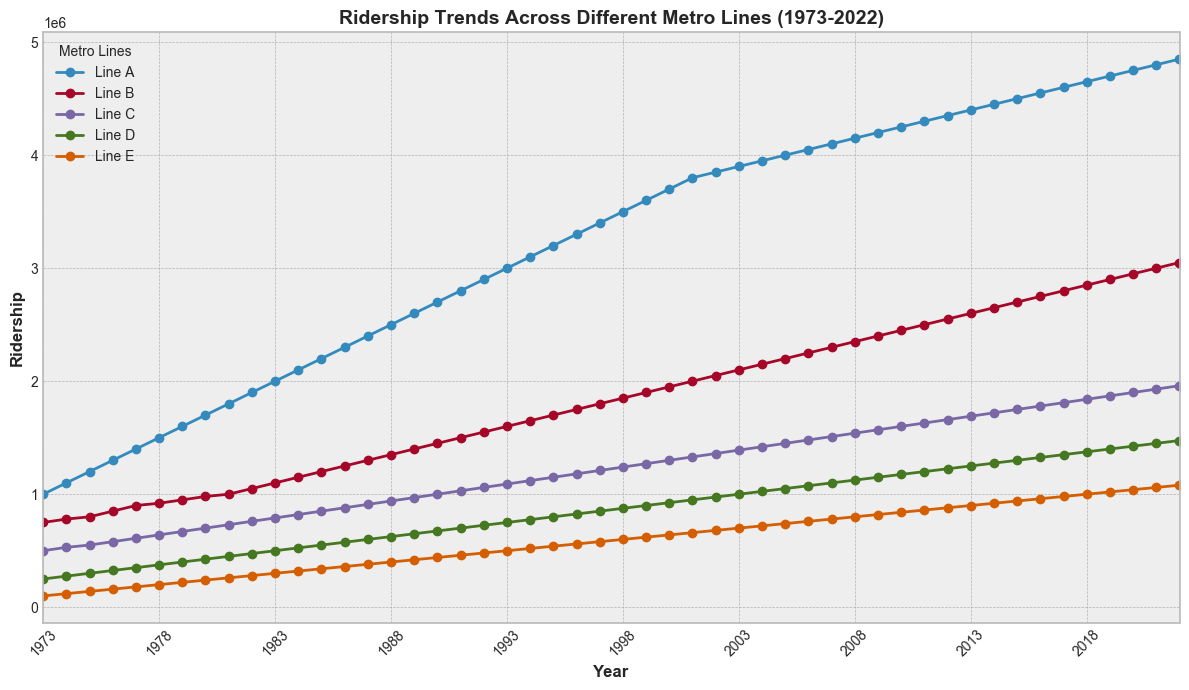What's the trend for Line A over the 50 years? To determine the trend for Line A, observe its plot from 1973 to 2022. We see a consistent upward movement throughout the years. Specifically, the ridership starts at 1,000,000 in 1973 and rises steadily to 4,850,000 by 2022.
Answer: Steadily increasing During which years did Line D have the sharpest increase in ridership? To determine the sharpest increase, we need to identify the year-over-year differences in Line D's ridership. The sharpest increase appears to be during 2002-2003 when ridership grew from 975,000 to 1,000,000, an increase of 25,000.
Answer: 2002-2003 Which line had the highest ridership in 1990, and what was the value? Look at the ridership values for all lines in 1990. Line A had 2,700,000, Line B had 1,450,000, Line C had 1,000,000, Line D had 675,000, and Line E had 440,000. Thus, Line A had the highest ridership in 1990.
Answer: Line A, 2,700,000 Compare the ridership of Line B and Line E in 2005. Which line had higher ridership, and by how much? In 2005, Line B had 2,200,000 riders and Line E had 740,000 riders. Subtract the ridership of Line E from Line B to find the difference: 2,200,000 - 740,000 = 1,460,000.
Answer: Line B, by 1,460,000 In which year did Line C reach a ridership of over 1,500,000 for the first time? Examine the ridership data for Line C year by year. In 2010, Line C's ridership is 1,600,000, and this is the first year it surpasses 1,500,000.
Answer: 2010 What was the average ridership for Line E from 1980 to 1985? Add the ridership numbers for Line E from 1980 to 1985 and divide by the number of years. (240,000 + 260,000 + 280,000 + 300,000 + 320,000 + 340,000) / 6 = 1,740,000 / 6 = 290,000.
Answer: 290,000 Did any line experience a decrease in ridership in a particular year? Review each line's ridership year-over-year. All lines show either a steady increase or constant gains, indicating no decreases in any particular year.
Answer: No Which year had the highest total ridership across all lines? Calculate the sum of the ridership for all lines for each year. The highest total ridership is in 2022 with sums: 4,850,000 (Line A) + 3,050,000 (Line B) + 1,960,000 (Line C) + 1,475,000 (Line D) + 1,080,000 (Line E) = 12,415,000.
Answer: 2022 By how much did the ridership of Line A increase from 1973 to 2022? Subtract the ridership of Line A in 1973 from its ridership in 2022: 4,850,000 - 1,000,000 = 3,850,000.
Answer: 3,850,000 